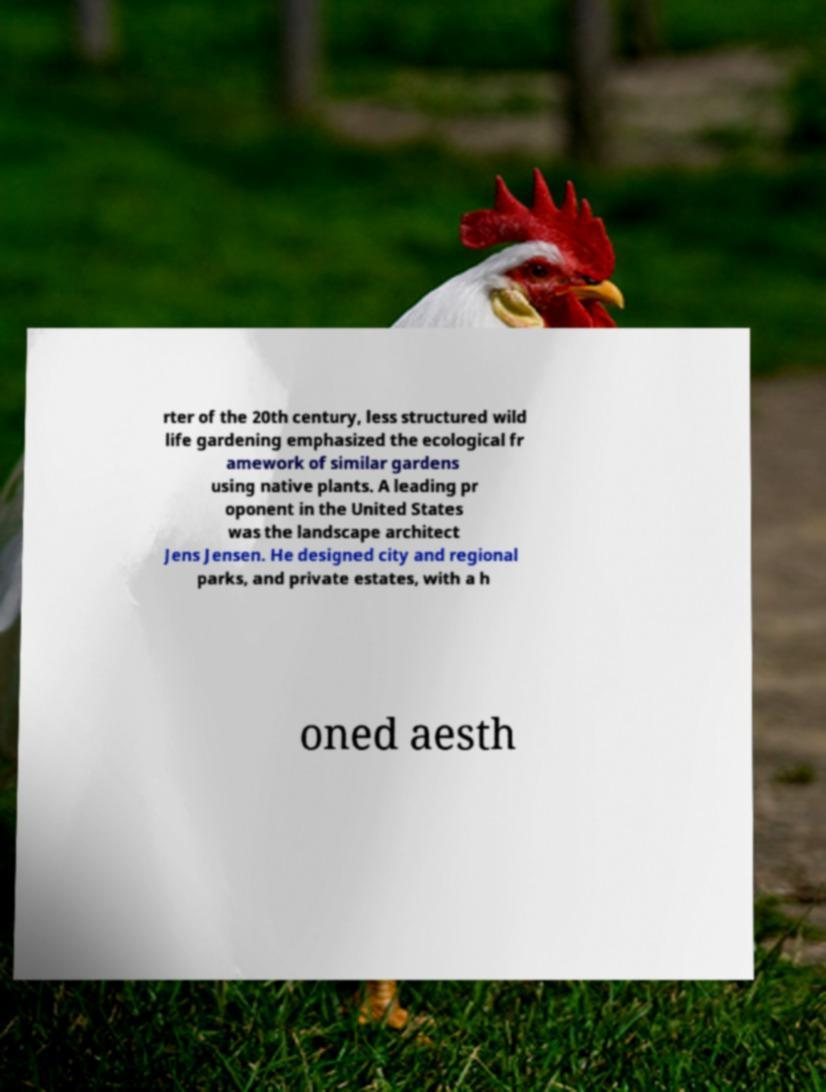Please identify and transcribe the text found in this image. rter of the 20th century, less structured wild life gardening emphasized the ecological fr amework of similar gardens using native plants. A leading pr oponent in the United States was the landscape architect Jens Jensen. He designed city and regional parks, and private estates, with a h oned aesth 